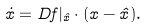<formula> <loc_0><loc_0><loc_500><loc_500>\dot { x } = D { f } | _ { \hat { x } } \cdot ( { x } - \hat { x } ) .</formula> 